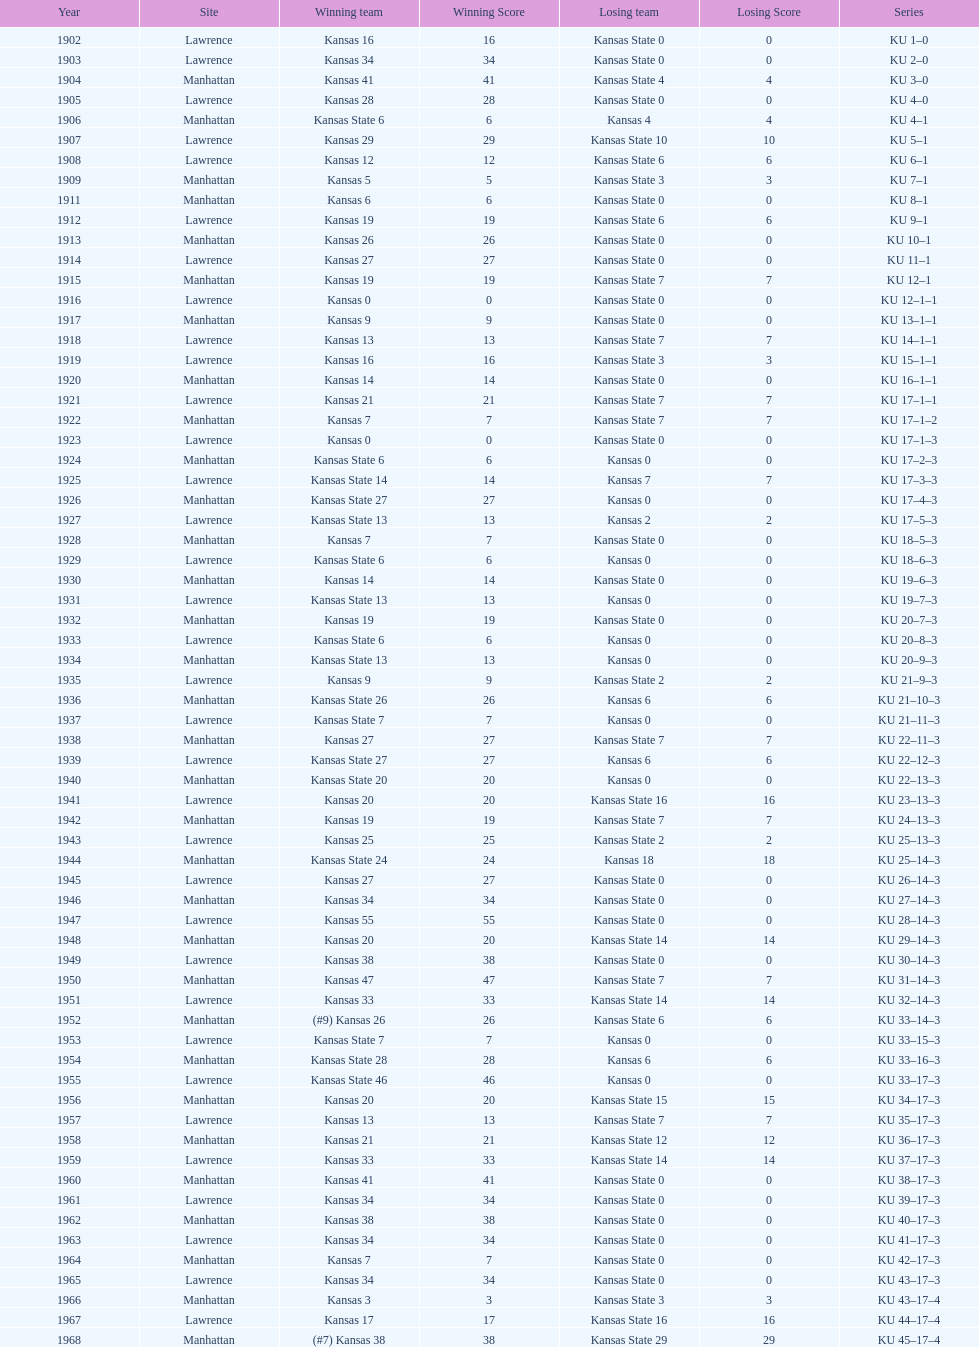When was the last time kansas state lost with 0 points in manhattan? 1964. 